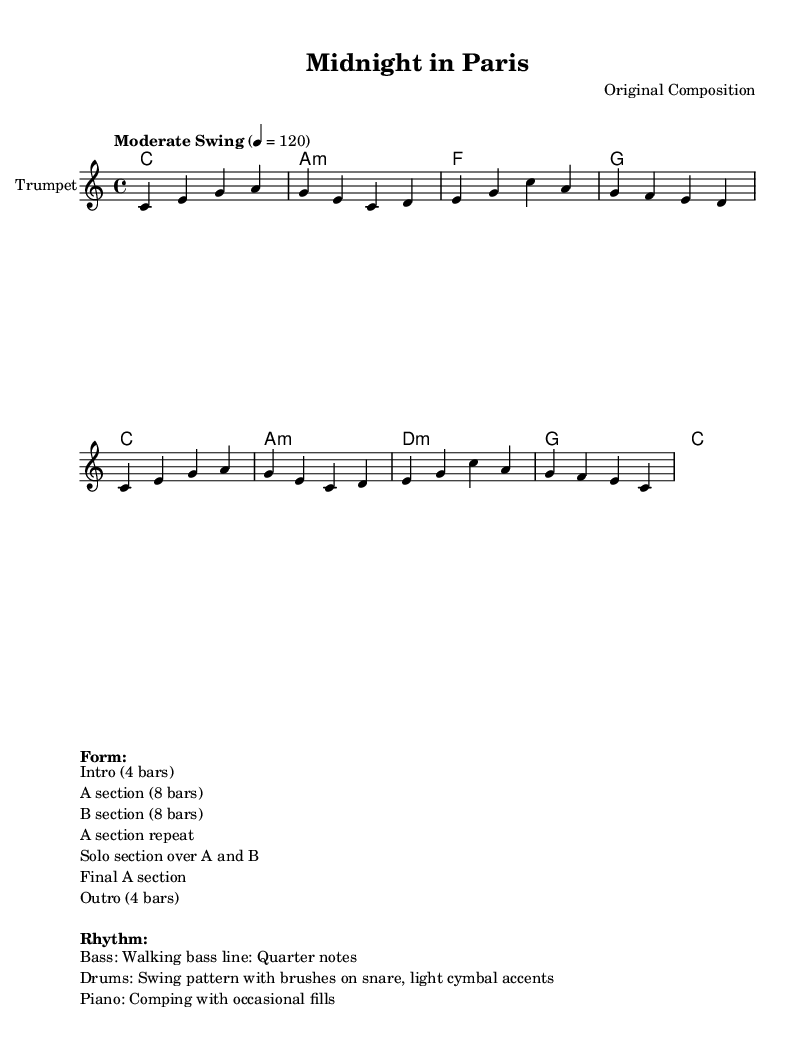What is the key signature of this music? The key signature shown in the music indicates C major, which has no sharps or flats. This can be determined by looking for the symbol indicating the key signature at the beginning of the staff.
Answer: C major What is the time signature of this piece? The time signature is shown as 4/4, which means there are four beats in each measure and the quarter note is one beat. This is found in the notation at the beginning of the score.
Answer: 4/4 What is the tempo marking indicated? The tempo marking states "Moderate Swing" with a metronome marking of 4 = 120, which informs the performers to play at a moderate swing feel at this speed. This is noted in the header section of the music.
Answer: Moderate Swing How many bars are in the A section? The A section consists of 8 bars as indicated in the structure section that clearly states "A section (8 bars)". This requires counting the measures labeled in that section.
Answer: 8 bars What instruments are featured in this piece? The piece features a trumpet as indicated by the instrument name written in the staff, which specifies the solo voice of the arrangement.
Answer: Trumpet How many total sections are indicated in the form? There are six total sections indicated in the form as seen in the description where each section of the music is listed. So, when counting them, you will find "Intro," "A section," "B section," "A section repeat," "Solo section," and "Final A section," adding up to six.
Answer: 6 